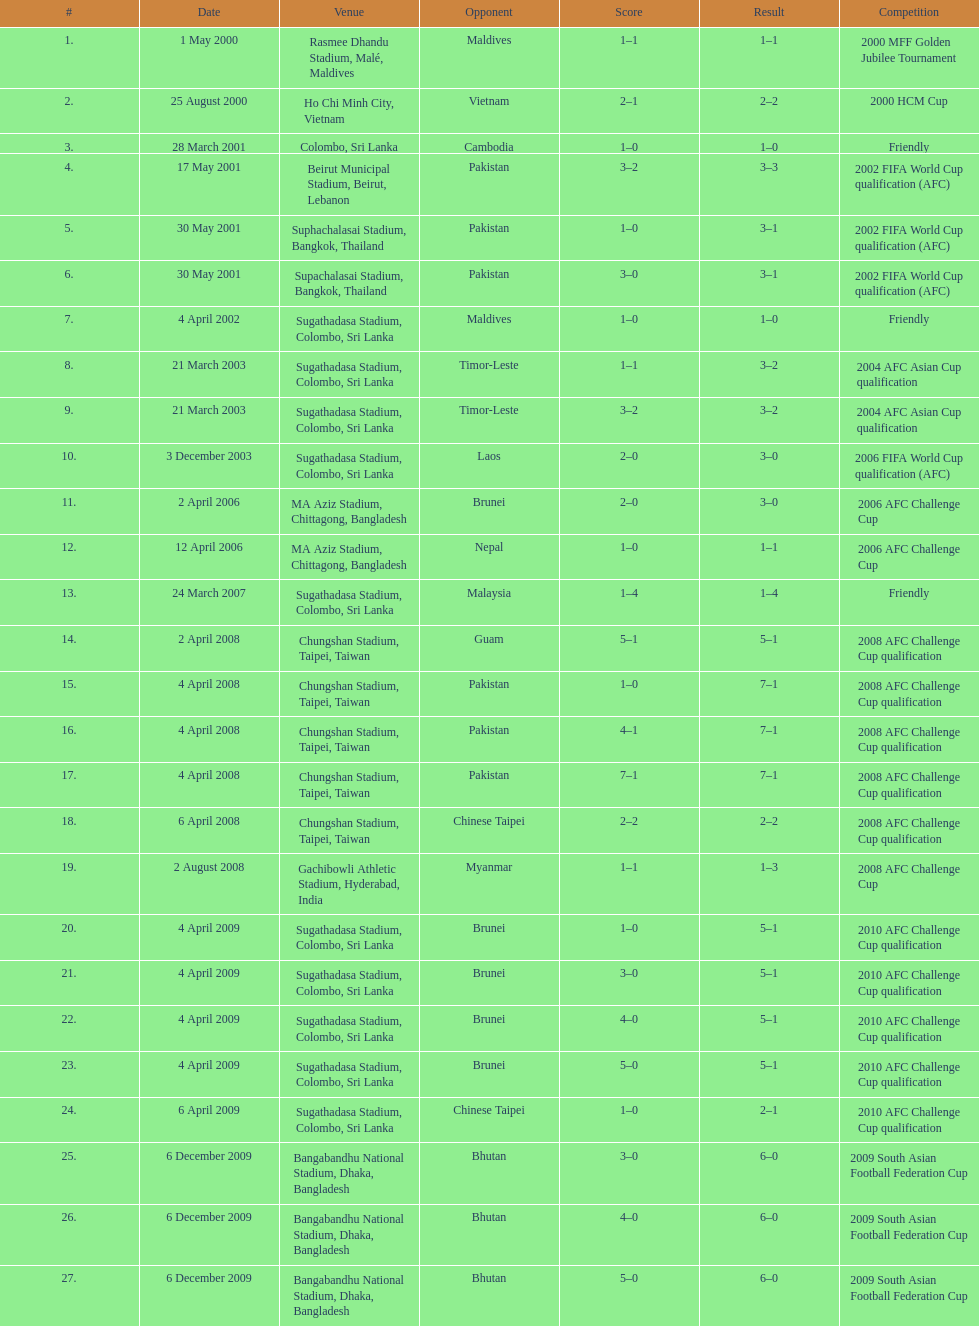Were more contests held in april or december? April. 